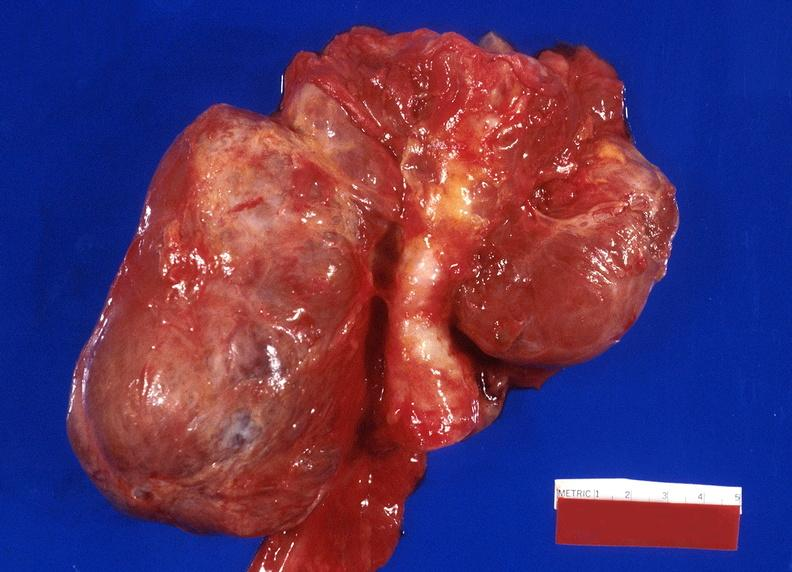what is present?
Answer the question using a single word or phrase. Endocrine 